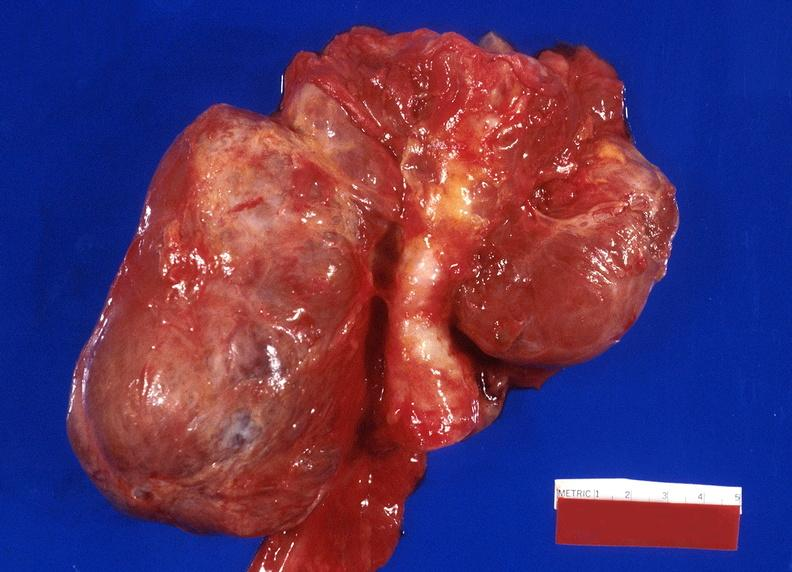what is present?
Answer the question using a single word or phrase. Endocrine 